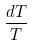<formula> <loc_0><loc_0><loc_500><loc_500>\frac { d T } { T }</formula> 